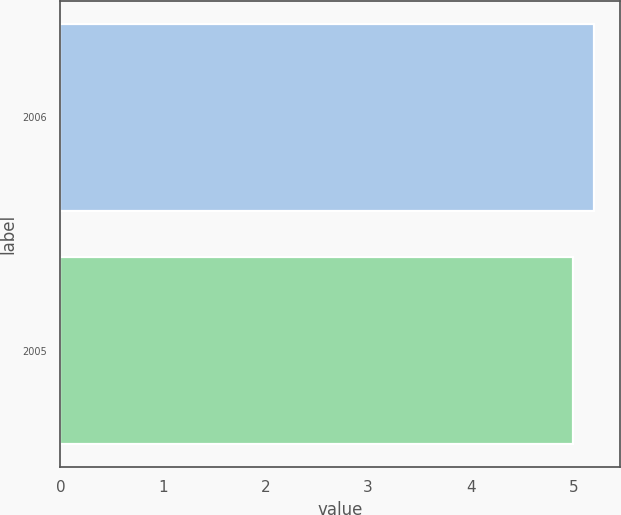<chart> <loc_0><loc_0><loc_500><loc_500><bar_chart><fcel>2006<fcel>2005<nl><fcel>5.2<fcel>5<nl></chart> 